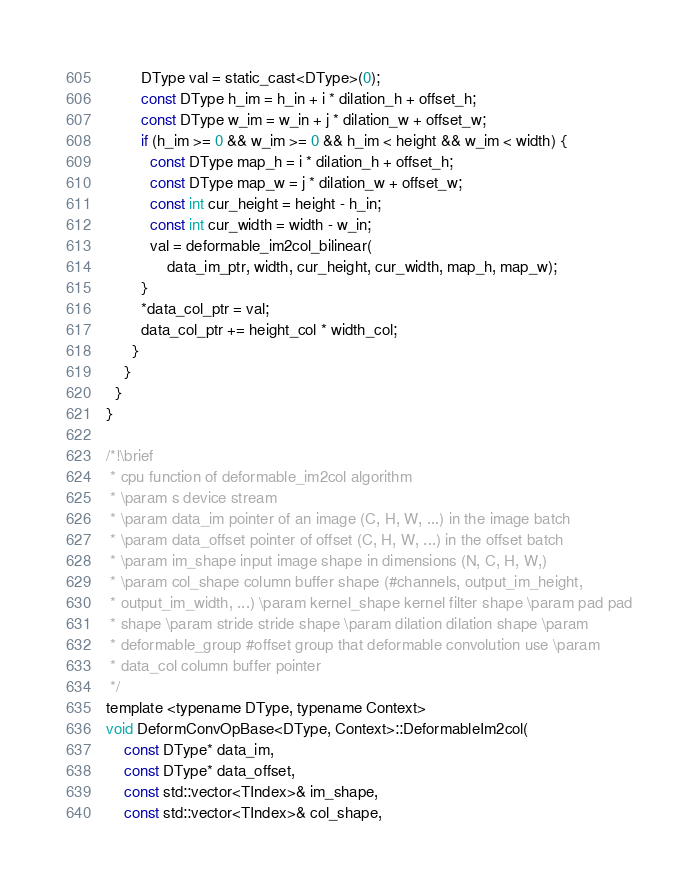<code> <loc_0><loc_0><loc_500><loc_500><_Cuda_>        DType val = static_cast<DType>(0);
        const DType h_im = h_in + i * dilation_h + offset_h;
        const DType w_im = w_in + j * dilation_w + offset_w;
        if (h_im >= 0 && w_im >= 0 && h_im < height && w_im < width) {
          const DType map_h = i * dilation_h + offset_h;
          const DType map_w = j * dilation_w + offset_w;
          const int cur_height = height - h_in;
          const int cur_width = width - w_in;
          val = deformable_im2col_bilinear(
              data_im_ptr, width, cur_height, cur_width, map_h, map_w);
        }
        *data_col_ptr = val;
        data_col_ptr += height_col * width_col;
      }
    }
  }
}

/*!\brief
 * cpu function of deformable_im2col algorithm
 * \param s device stream
 * \param data_im pointer of an image (C, H, W, ...) in the image batch
 * \param data_offset pointer of offset (C, H, W, ...) in the offset batch
 * \param im_shape input image shape in dimensions (N, C, H, W,)
 * \param col_shape column buffer shape (#channels, output_im_height,
 * output_im_width, ...) \param kernel_shape kernel filter shape \param pad pad
 * shape \param stride stride shape \param dilation dilation shape \param
 * deformable_group #offset group that deformable convolution use \param
 * data_col column buffer pointer
 */
template <typename DType, typename Context>
void DeformConvOpBase<DType, Context>::DeformableIm2col(
    const DType* data_im,
    const DType* data_offset,
    const std::vector<TIndex>& im_shape,
    const std::vector<TIndex>& col_shape,</code> 